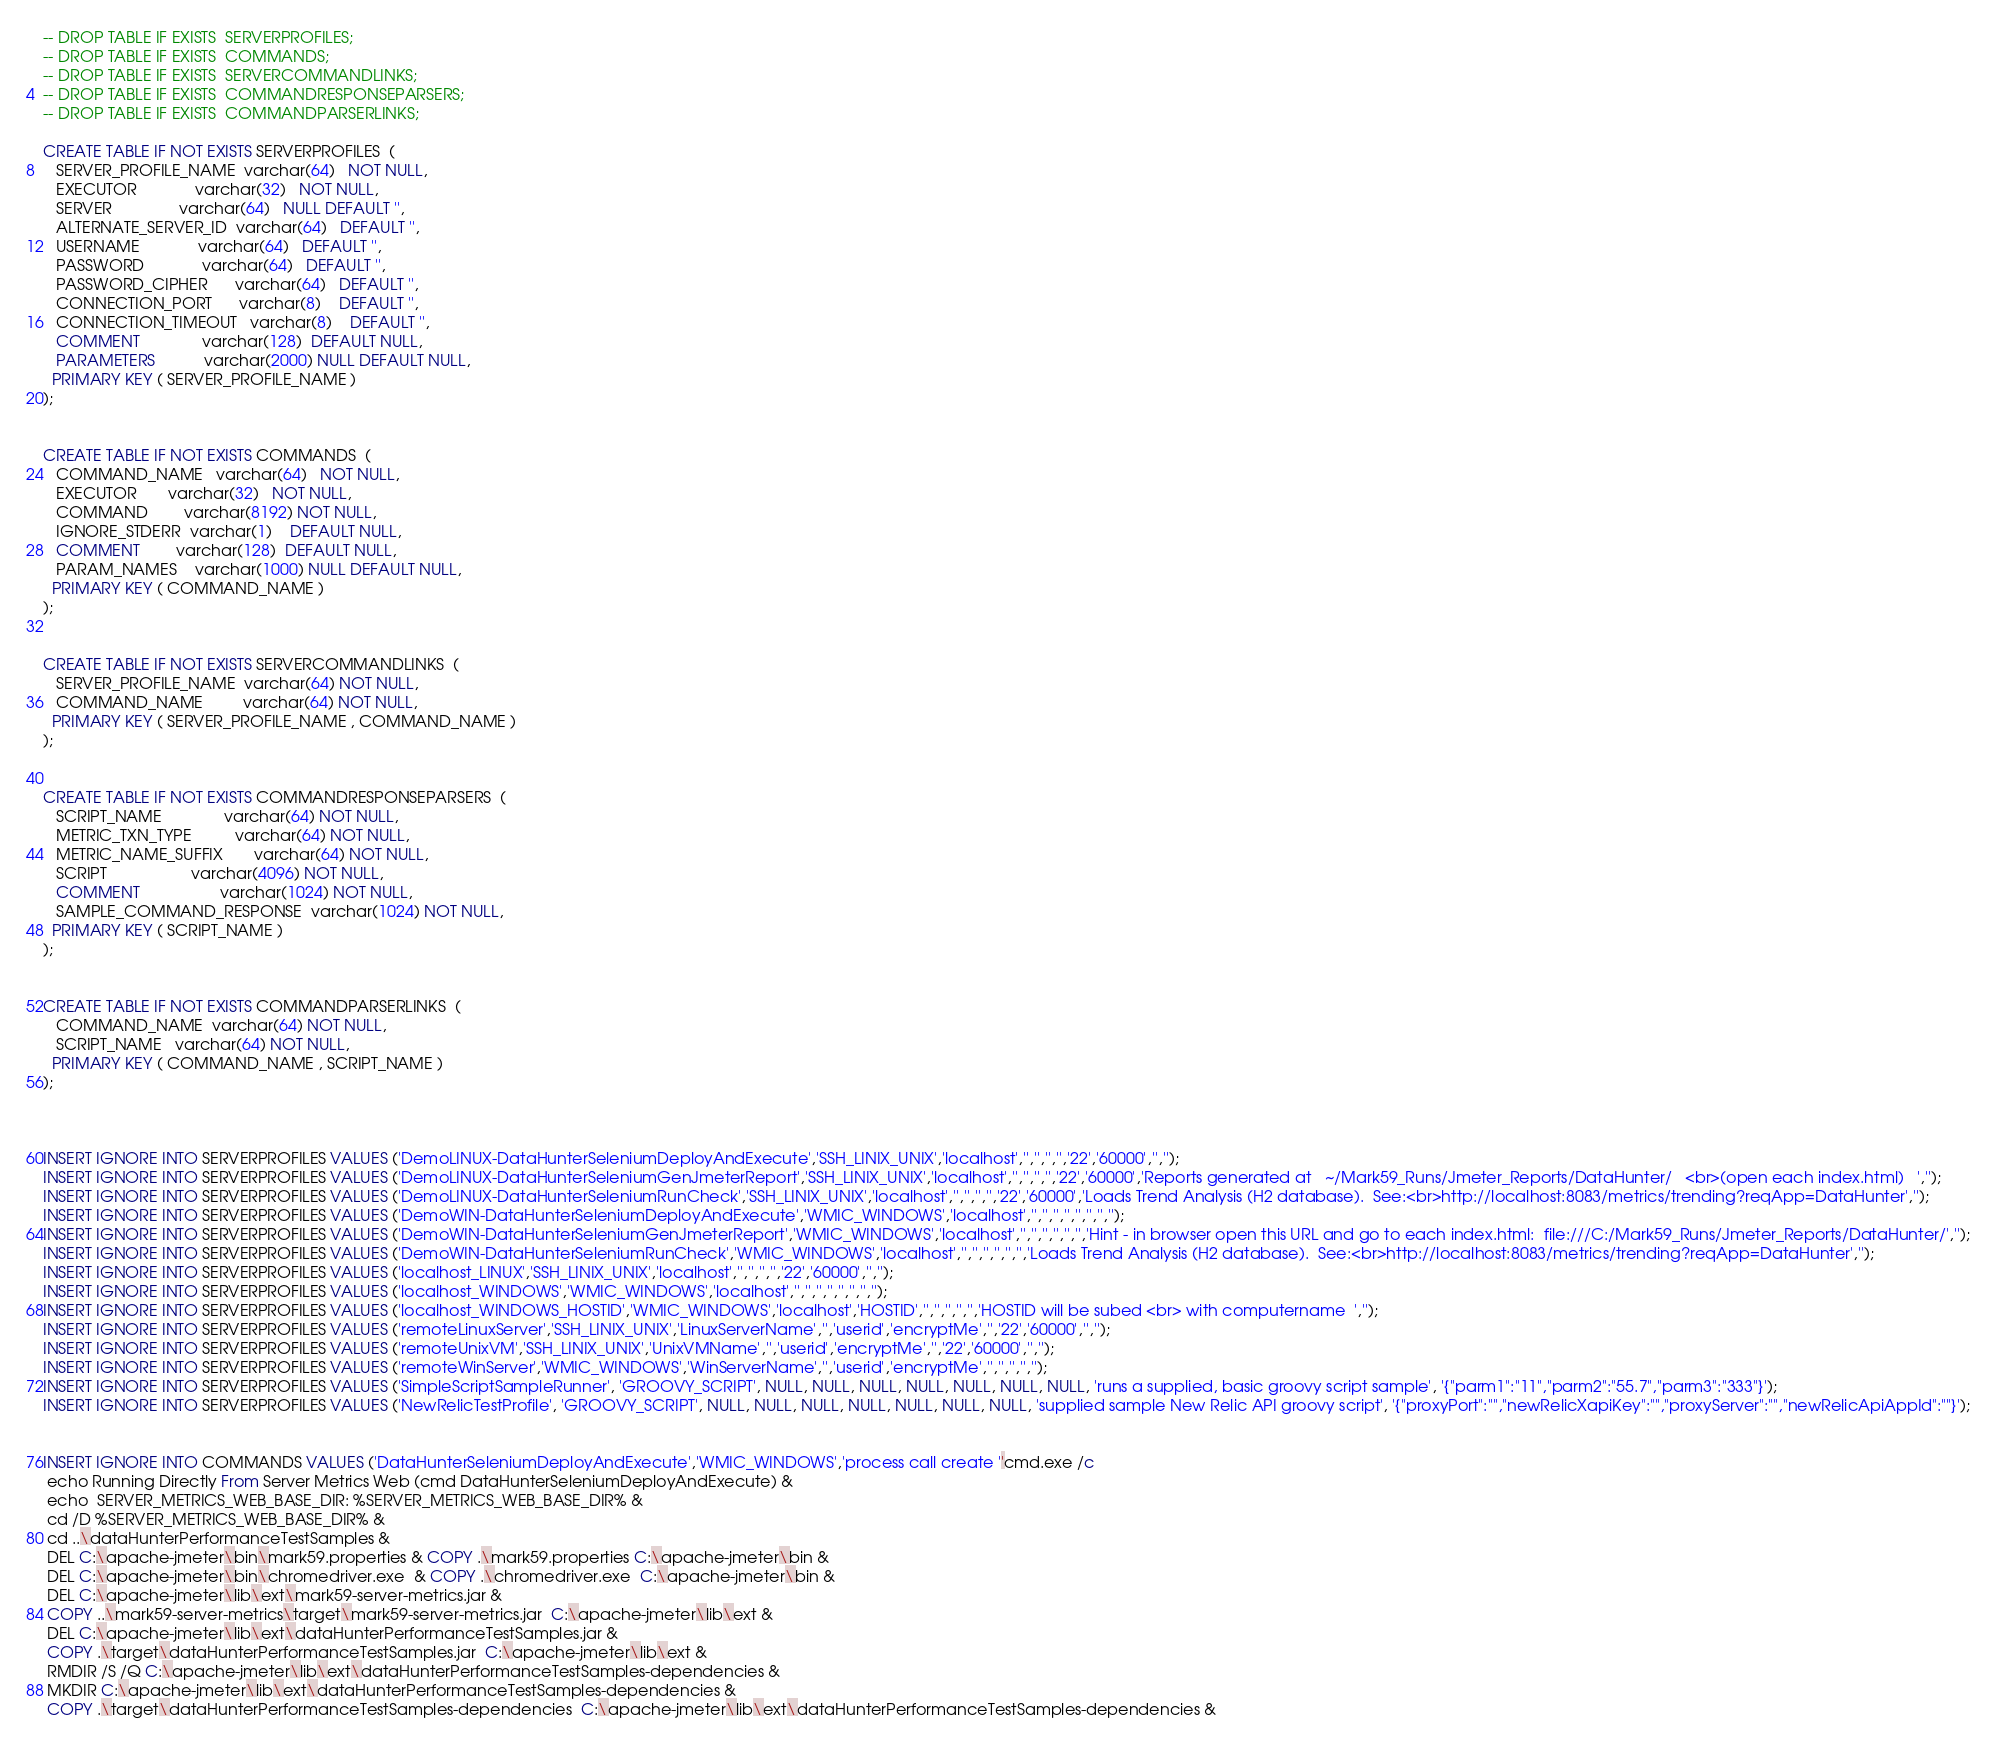<code> <loc_0><loc_0><loc_500><loc_500><_SQL_>-- DROP TABLE IF EXISTS  SERVERPROFILES;
-- DROP TABLE IF EXISTS  COMMANDS;
-- DROP TABLE IF EXISTS  SERVERCOMMANDLINKS;
-- DROP TABLE IF EXISTS  COMMANDRESPONSEPARSERS;
-- DROP TABLE IF EXISTS  COMMANDPARSERLINKS;

CREATE TABLE IF NOT EXISTS SERVERPROFILES  (
   SERVER_PROFILE_NAME  varchar(64)   NOT NULL,
   EXECUTOR             varchar(32)   NOT NULL,  
   SERVER               varchar(64)   NULL DEFAULT '',
   ALTERNATE_SERVER_ID  varchar(64)   DEFAULT '',
   USERNAME             varchar(64)   DEFAULT '',
   PASSWORD             varchar(64)   DEFAULT '',
   PASSWORD_CIPHER      varchar(64)   DEFAULT '',
   CONNECTION_PORT      varchar(8)    DEFAULT '',
   CONNECTION_TIMEOUT   varchar(8)    DEFAULT '',
   COMMENT              varchar(128)  DEFAULT NULL,
   PARAMETERS           varchar(2000) NULL DEFAULT NULL,
  PRIMARY KEY ( SERVER_PROFILE_NAME )
); 


CREATE TABLE IF NOT EXISTS COMMANDS  (
   COMMAND_NAME   varchar(64)   NOT NULL,
   EXECUTOR       varchar(32)   NOT NULL,
   COMMAND        varchar(8192) NOT NULL,
   IGNORE_STDERR  varchar(1)    DEFAULT NULL,
   COMMENT        varchar(128)  DEFAULT NULL,
   PARAM_NAMES    varchar(1000) NULL DEFAULT NULL,
  PRIMARY KEY ( COMMAND_NAME )
); 


CREATE TABLE IF NOT EXISTS SERVERCOMMANDLINKS  (
   SERVER_PROFILE_NAME  varchar(64) NOT NULL,
   COMMAND_NAME         varchar(64) NOT NULL,
  PRIMARY KEY ( SERVER_PROFILE_NAME , COMMAND_NAME )
);


CREATE TABLE IF NOT EXISTS COMMANDRESPONSEPARSERS  (
   SCRIPT_NAME              varchar(64) NOT NULL,
   METRIC_TXN_TYPE          varchar(64) NOT NULL,
   METRIC_NAME_SUFFIX       varchar(64) NOT NULL,
   SCRIPT                   varchar(4096) NOT NULL,
   COMMENT                  varchar(1024) NOT NULL,
   SAMPLE_COMMAND_RESPONSE  varchar(1024) NOT NULL,
  PRIMARY KEY ( SCRIPT_NAME )
); 


CREATE TABLE IF NOT EXISTS COMMANDPARSERLINKS  (
   COMMAND_NAME  varchar(64) NOT NULL,
   SCRIPT_NAME   varchar(64) NOT NULL,
  PRIMARY KEY ( COMMAND_NAME , SCRIPT_NAME )
); 



INSERT IGNORE INTO SERVERPROFILES VALUES ('DemoLINUX-DataHunterSeleniumDeployAndExecute','SSH_LINIX_UNIX','localhost','','','','','22','60000','','');
INSERT IGNORE INTO SERVERPROFILES VALUES ('DemoLINUX-DataHunterSeleniumGenJmeterReport','SSH_LINIX_UNIX','localhost','','','','','22','60000','Reports generated at   ~/Mark59_Runs/Jmeter_Reports/DataHunter/   <br>(open each index.html)   ','');
INSERT IGNORE INTO SERVERPROFILES VALUES ('DemoLINUX-DataHunterSeleniumRunCheck','SSH_LINIX_UNIX','localhost','','','','','22','60000','Loads Trend Analysis (H2 database).  See:<br>http://localhost:8083/metrics/trending?reqApp=DataHunter','');
INSERT IGNORE INTO SERVERPROFILES VALUES ('DemoWIN-DataHunterSeleniumDeployAndExecute','WMIC_WINDOWS','localhost','','','','','','','','');
INSERT IGNORE INTO SERVERPROFILES VALUES ('DemoWIN-DataHunterSeleniumGenJmeterReport','WMIC_WINDOWS','localhost','','','','','','','Hint - in browser open this URL and go to each index.html:  file:///C:/Mark59_Runs/Jmeter_Reports/DataHunter/','');
INSERT IGNORE INTO SERVERPROFILES VALUES ('DemoWIN-DataHunterSeleniumRunCheck','WMIC_WINDOWS','localhost','','','','','','','Loads Trend Analysis (H2 database).  See:<br>http://localhost:8083/metrics/trending?reqApp=DataHunter','');
INSERT IGNORE INTO SERVERPROFILES VALUES ('localhost_LINUX','SSH_LINIX_UNIX','localhost','','','','','22','60000','','');
INSERT IGNORE INTO SERVERPROFILES VALUES ('localhost_WINDOWS','WMIC_WINDOWS','localhost','','','','','','','','');
INSERT IGNORE INTO SERVERPROFILES VALUES ('localhost_WINDOWS_HOSTID','WMIC_WINDOWS','localhost','HOSTID','','','','','','HOSTID will be subed <br> with computername  ','');
INSERT IGNORE INTO SERVERPROFILES VALUES ('remoteLinuxServer','SSH_LINIX_UNIX','LinuxServerName','','userid','encryptMe','','22','60000','','');
INSERT IGNORE INTO SERVERPROFILES VALUES ('remoteUnixVM','SSH_LINIX_UNIX','UnixVMName','','userid','encryptMe','','22','60000','','');
INSERT IGNORE INTO SERVERPROFILES VALUES ('remoteWinServer','WMIC_WINDOWS','WinServerName','','userid','encryptMe','','','','','');
INSERT IGNORE INTO SERVERPROFILES VALUES ('SimpleScriptSampleRunner', 'GROOVY_SCRIPT', NULL, NULL, NULL, NULL, NULL, NULL, NULL, 'runs a supplied, basic groovy script sample', '{"parm1":"11","parm2":"55.7","parm3":"333"}');
INSERT IGNORE INTO SERVERPROFILES VALUES ('NewRelicTestProfile', 'GROOVY_SCRIPT', NULL, NULL, NULL, NULL, NULL, NULL, NULL, 'supplied sample New Relic API groovy script', '{"proxyPort":"","newRelicXapiKey":"","proxyServer":"","newRelicApiAppId":""}');    


INSERT IGNORE INTO COMMANDS VALUES ('DataHunterSeleniumDeployAndExecute','WMIC_WINDOWS','process call create ''cmd.exe /c 
 echo Running Directly From Server Metrics Web (cmd DataHunterSeleniumDeployAndExecute) & 
 echo  SERVER_METRICS_WEB_BASE_DIR: %SERVER_METRICS_WEB_BASE_DIR% & 
 cd /D %SERVER_METRICS_WEB_BASE_DIR% &  
 cd ..\dataHunterPerformanceTestSamples & 
 DEL C:\apache-jmeter\bin\mark59.properties & COPY .\mark59.properties C:\apache-jmeter\bin &
 DEL C:\apache-jmeter\bin\chromedriver.exe  & COPY .\chromedriver.exe  C:\apache-jmeter\bin &
 DEL C:\apache-jmeter\lib\ext\mark59-server-metrics.jar &
 COPY ..\mark59-server-metrics\target\mark59-server-metrics.jar  C:\apache-jmeter\lib\ext & 
 DEL C:\apache-jmeter\lib\ext\dataHunterPerformanceTestSamples.jar & 
 COPY .\target\dataHunterPerformanceTestSamples.jar  C:\apache-jmeter\lib\ext &
 RMDIR /S /Q C:\apache-jmeter\lib\ext\dataHunterPerformanceTestSamples-dependencies &
 MKDIR C:\apache-jmeter\lib\ext\dataHunterPerformanceTestSamples-dependencies &
 COPY .\target\dataHunterPerformanceTestSamples-dependencies  C:\apache-jmeter\lib\ext\dataHunterPerformanceTestSamples-dependencies &
</code> 